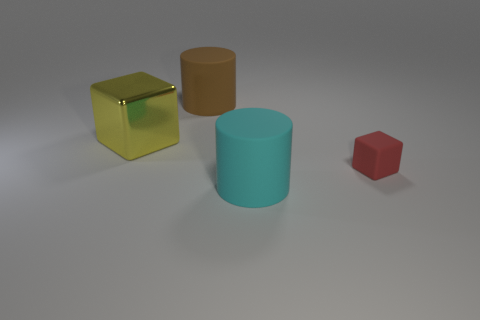Add 4 green metal cylinders. How many objects exist? 8 Subtract 2 cylinders. How many cylinders are left? 0 Subtract all blue blocks. Subtract all gray balls. How many blocks are left? 2 Subtract all red blocks. How many cyan cylinders are left? 1 Subtract all yellow metal objects. Subtract all matte cylinders. How many objects are left? 1 Add 3 matte cylinders. How many matte cylinders are left? 5 Add 3 tiny yellow metallic spheres. How many tiny yellow metallic spheres exist? 3 Subtract 0 purple cylinders. How many objects are left? 4 